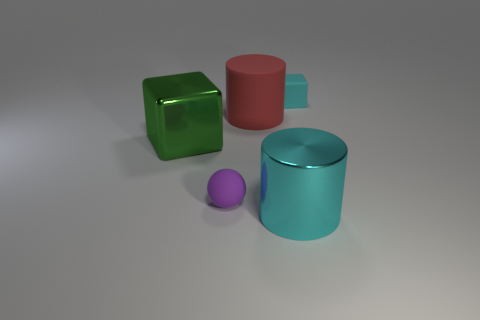Add 2 large objects. How many objects exist? 7 Subtract all cylinders. How many objects are left? 3 Subtract 0 gray balls. How many objects are left? 5 Subtract all purple matte cubes. Subtract all blocks. How many objects are left? 3 Add 4 cyan cubes. How many cyan cubes are left? 5 Add 5 small things. How many small things exist? 7 